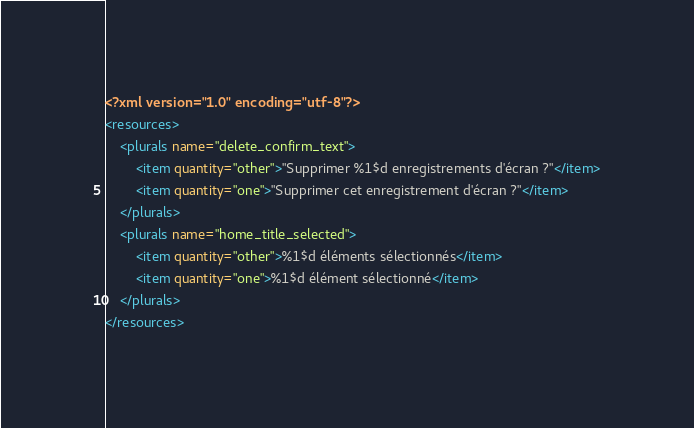<code> <loc_0><loc_0><loc_500><loc_500><_XML_><?xml version="1.0" encoding="utf-8"?>
<resources>
    <plurals name="delete_confirm_text">
        <item quantity="other">"Supprimer %1$d enregistrements d'écran ?"</item>
        <item quantity="one">"Supprimer cet enregistrement d'écran ?"</item>
    </plurals>
    <plurals name="home_title_selected">
        <item quantity="other">%1$d éléments sélectionnés</item>
        <item quantity="one">%1$d élément sélectionné</item>
    </plurals>
</resources>
</code> 